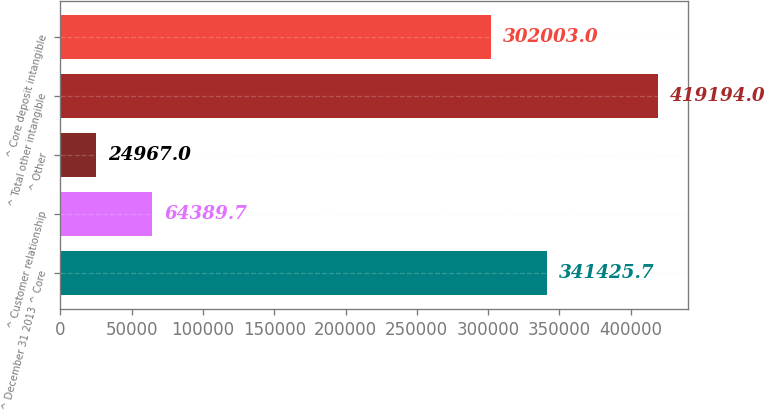Convert chart to OTSL. <chart><loc_0><loc_0><loc_500><loc_500><bar_chart><fcel>^ December 31 2013 ^ Core<fcel>^ Customer relationship<fcel>^ Other<fcel>^ Total other intangible<fcel>^ Core deposit intangible<nl><fcel>341426<fcel>64389.7<fcel>24967<fcel>419194<fcel>302003<nl></chart> 